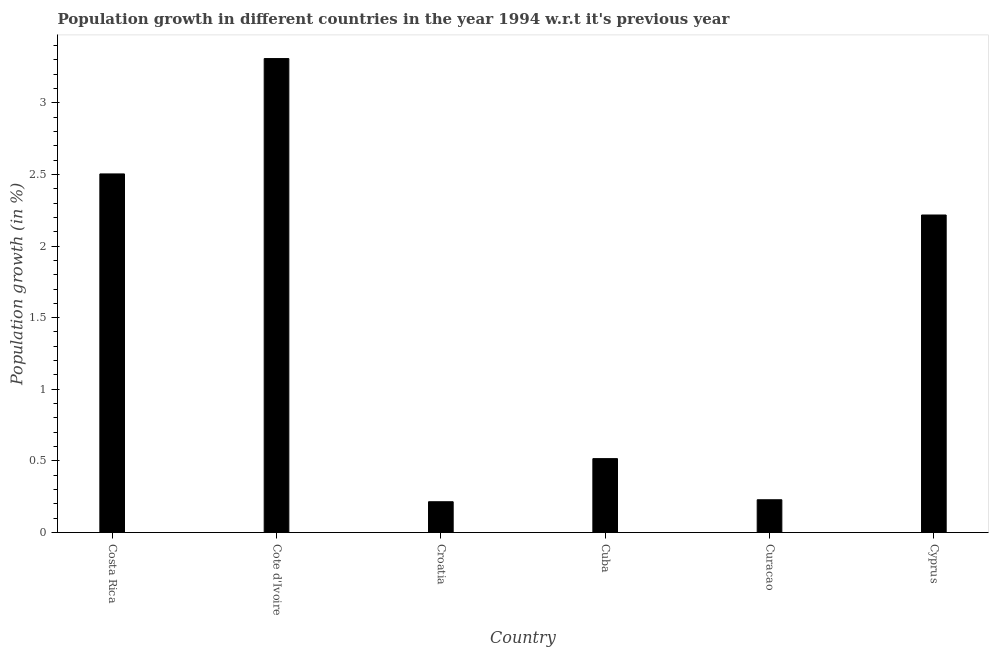Does the graph contain grids?
Your answer should be very brief. No. What is the title of the graph?
Make the answer very short. Population growth in different countries in the year 1994 w.r.t it's previous year. What is the label or title of the Y-axis?
Provide a succinct answer. Population growth (in %). What is the population growth in Cote d'Ivoire?
Ensure brevity in your answer.  3.31. Across all countries, what is the maximum population growth?
Your response must be concise. 3.31. Across all countries, what is the minimum population growth?
Offer a terse response. 0.22. In which country was the population growth maximum?
Offer a very short reply. Cote d'Ivoire. In which country was the population growth minimum?
Give a very brief answer. Croatia. What is the sum of the population growth?
Make the answer very short. 8.99. What is the difference between the population growth in Costa Rica and Cuba?
Ensure brevity in your answer.  1.99. What is the average population growth per country?
Offer a terse response. 1.5. What is the median population growth?
Ensure brevity in your answer.  1.37. What is the ratio of the population growth in Costa Rica to that in Cyprus?
Provide a short and direct response. 1.13. Is the population growth in Cote d'Ivoire less than that in Cuba?
Your answer should be very brief. No. What is the difference between the highest and the second highest population growth?
Your response must be concise. 0.81. What is the difference between the highest and the lowest population growth?
Provide a short and direct response. 3.09. Are all the bars in the graph horizontal?
Ensure brevity in your answer.  No. How many countries are there in the graph?
Your answer should be compact. 6. What is the Population growth (in %) of Costa Rica?
Give a very brief answer. 2.5. What is the Population growth (in %) in Cote d'Ivoire?
Ensure brevity in your answer.  3.31. What is the Population growth (in %) in Croatia?
Your response must be concise. 0.22. What is the Population growth (in %) in Cuba?
Offer a terse response. 0.52. What is the Population growth (in %) of Curacao?
Your answer should be compact. 0.23. What is the Population growth (in %) in Cyprus?
Your answer should be very brief. 2.22. What is the difference between the Population growth (in %) in Costa Rica and Cote d'Ivoire?
Provide a short and direct response. -0.81. What is the difference between the Population growth (in %) in Costa Rica and Croatia?
Offer a terse response. 2.29. What is the difference between the Population growth (in %) in Costa Rica and Cuba?
Provide a short and direct response. 1.99. What is the difference between the Population growth (in %) in Costa Rica and Curacao?
Your answer should be very brief. 2.27. What is the difference between the Population growth (in %) in Costa Rica and Cyprus?
Provide a short and direct response. 0.29. What is the difference between the Population growth (in %) in Cote d'Ivoire and Croatia?
Keep it short and to the point. 3.09. What is the difference between the Population growth (in %) in Cote d'Ivoire and Cuba?
Your response must be concise. 2.79. What is the difference between the Population growth (in %) in Cote d'Ivoire and Curacao?
Offer a terse response. 3.08. What is the difference between the Population growth (in %) in Cote d'Ivoire and Cyprus?
Offer a very short reply. 1.09. What is the difference between the Population growth (in %) in Croatia and Cuba?
Keep it short and to the point. -0.3. What is the difference between the Population growth (in %) in Croatia and Curacao?
Make the answer very short. -0.01. What is the difference between the Population growth (in %) in Croatia and Cyprus?
Provide a succinct answer. -2. What is the difference between the Population growth (in %) in Cuba and Curacao?
Your answer should be compact. 0.29. What is the difference between the Population growth (in %) in Cuba and Cyprus?
Give a very brief answer. -1.7. What is the difference between the Population growth (in %) in Curacao and Cyprus?
Offer a terse response. -1.99. What is the ratio of the Population growth (in %) in Costa Rica to that in Cote d'Ivoire?
Offer a terse response. 0.76. What is the ratio of the Population growth (in %) in Costa Rica to that in Croatia?
Make the answer very short. 11.63. What is the ratio of the Population growth (in %) in Costa Rica to that in Cuba?
Offer a terse response. 4.85. What is the ratio of the Population growth (in %) in Costa Rica to that in Curacao?
Your answer should be very brief. 10.93. What is the ratio of the Population growth (in %) in Costa Rica to that in Cyprus?
Provide a short and direct response. 1.13. What is the ratio of the Population growth (in %) in Cote d'Ivoire to that in Croatia?
Your answer should be very brief. 15.37. What is the ratio of the Population growth (in %) in Cote d'Ivoire to that in Cuba?
Keep it short and to the point. 6.41. What is the ratio of the Population growth (in %) in Cote d'Ivoire to that in Curacao?
Your answer should be compact. 14.44. What is the ratio of the Population growth (in %) in Cote d'Ivoire to that in Cyprus?
Keep it short and to the point. 1.49. What is the ratio of the Population growth (in %) in Croatia to that in Cuba?
Ensure brevity in your answer.  0.42. What is the ratio of the Population growth (in %) in Croatia to that in Curacao?
Your response must be concise. 0.94. What is the ratio of the Population growth (in %) in Croatia to that in Cyprus?
Keep it short and to the point. 0.1. What is the ratio of the Population growth (in %) in Cuba to that in Curacao?
Your answer should be very brief. 2.25. What is the ratio of the Population growth (in %) in Cuba to that in Cyprus?
Keep it short and to the point. 0.23. What is the ratio of the Population growth (in %) in Curacao to that in Cyprus?
Keep it short and to the point. 0.1. 